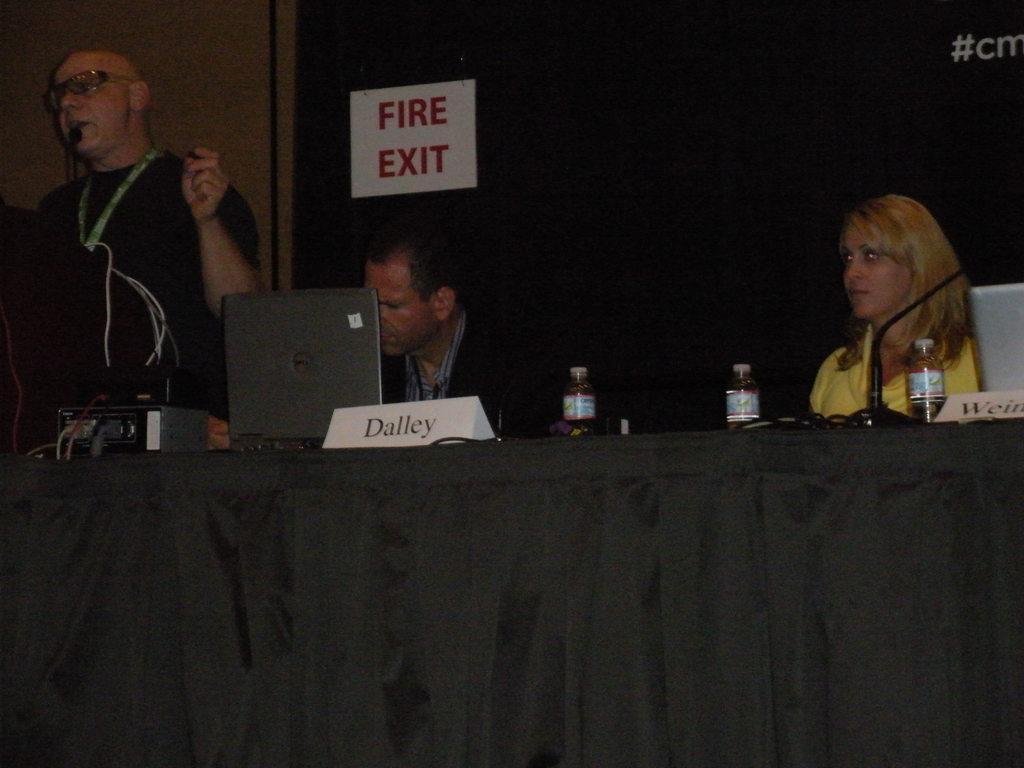Could you give a brief overview of what you see in this image? This is the man standing. I can see two people sitting. This is a table covered with a black cloth. I can see a laptop, water bottles, name boards, mike and an electronic devices are placed on the table. This looks like an fire exit board, which is attached to the wall. On the right side of the image, that looks like another laptop on the table. 